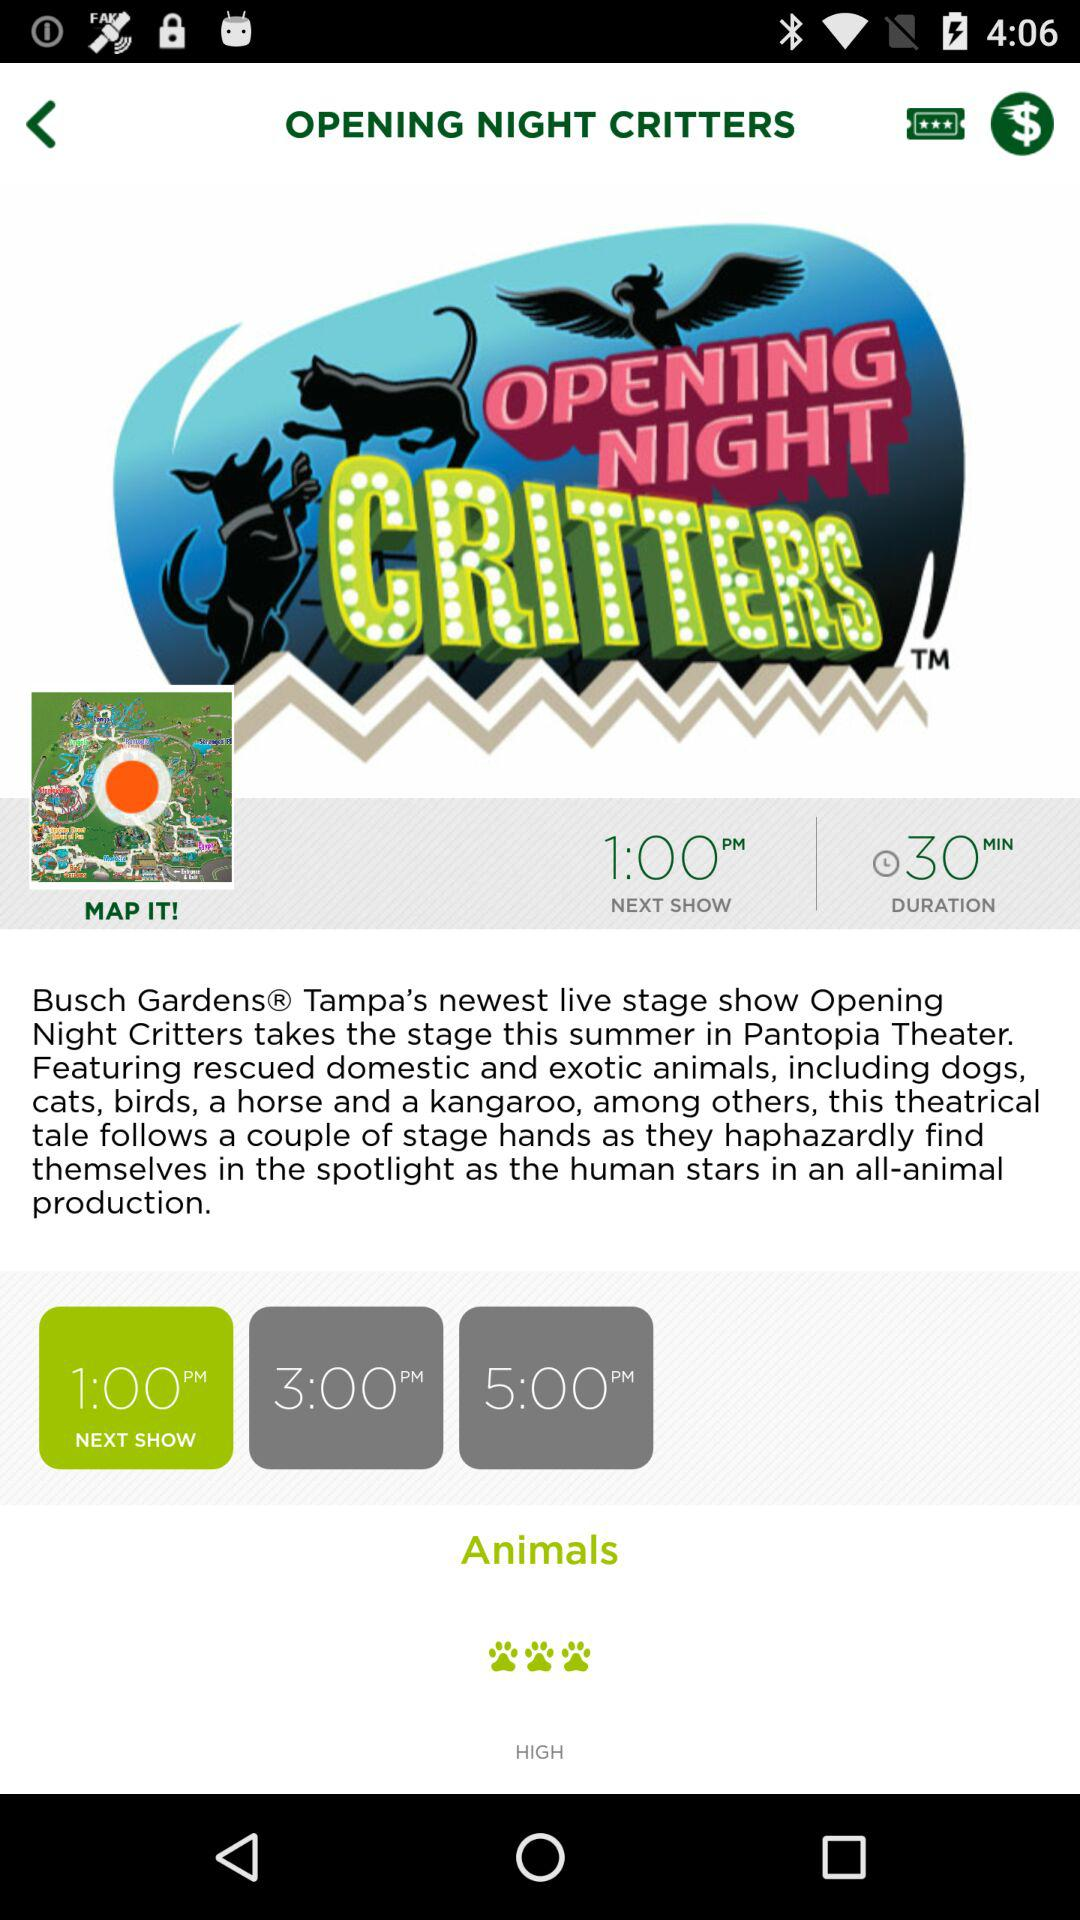What is the broadcast time for the next show? The broadcast time for the next show is 1:00 p.m. 